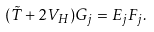Convert formula to latex. <formula><loc_0><loc_0><loc_500><loc_500>( \tilde { T } + 2 V _ { H } ) G _ { j } = E _ { j } F _ { j } .</formula> 